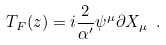Convert formula to latex. <formula><loc_0><loc_0><loc_500><loc_500>T _ { F } ( z ) = i { \frac { 2 } { \alpha ^ { \prime } } } \psi ^ { \mu } \partial X _ { \mu } \ .</formula> 